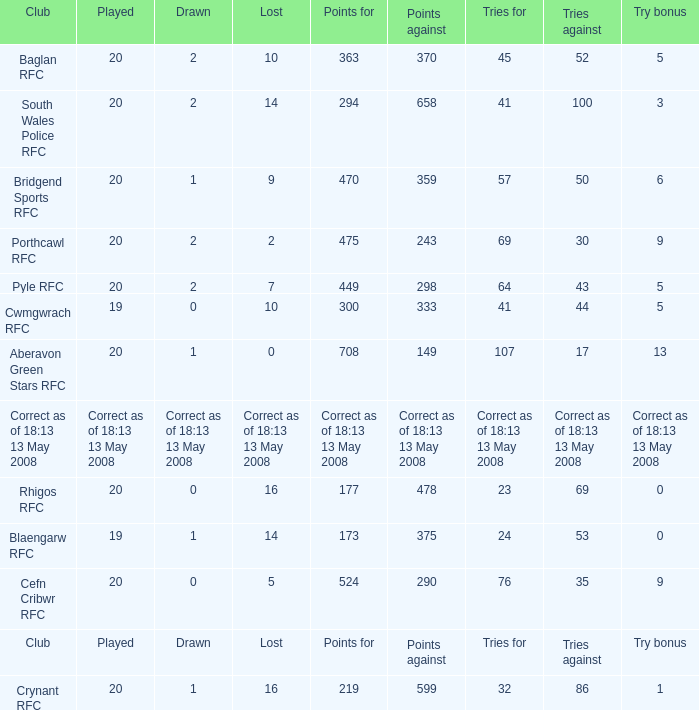What is the points when the try bonus is 1? 219.0. 